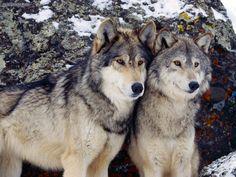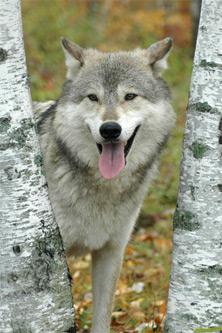The first image is the image on the left, the second image is the image on the right. Given the left and right images, does the statement "The combined images contain three live animals, two animals have wide-open mouths, and at least two of the animals are wolves." hold true? Answer yes or no. No. The first image is the image on the left, the second image is the image on the right. Evaluate the accuracy of this statement regarding the images: "There are three wolves.". Is it true? Answer yes or no. Yes. 